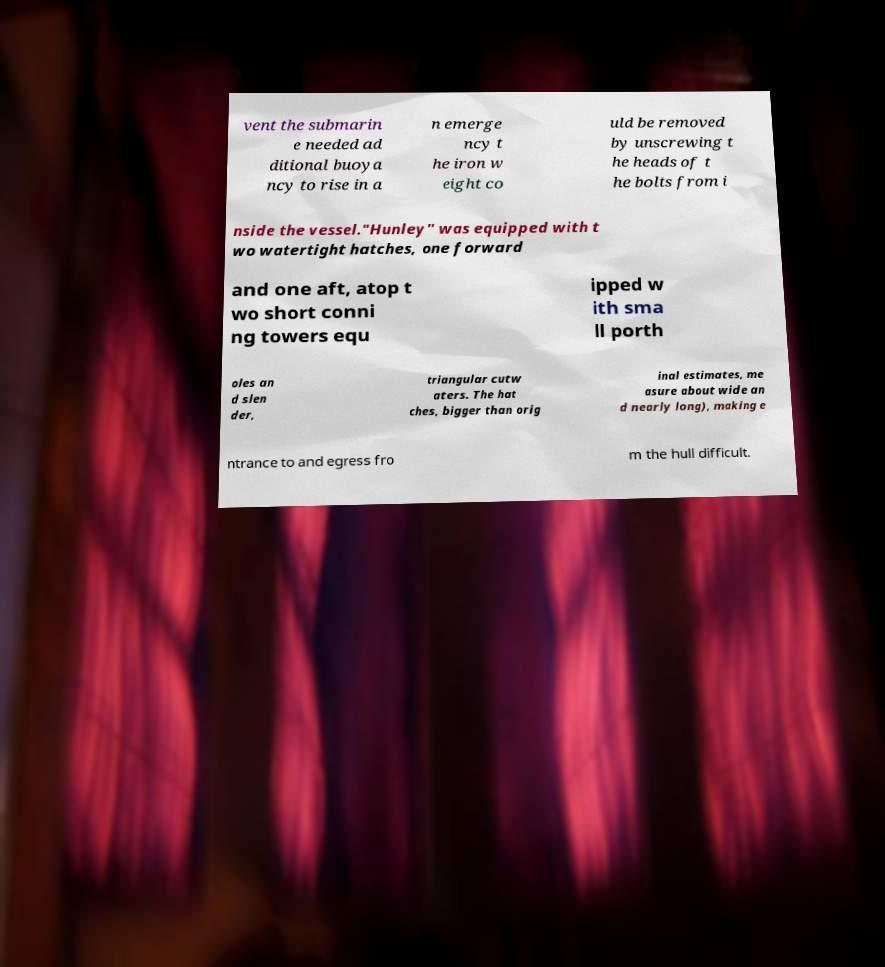Could you extract and type out the text from this image? vent the submarin e needed ad ditional buoya ncy to rise in a n emerge ncy t he iron w eight co uld be removed by unscrewing t he heads of t he bolts from i nside the vessel."Hunley" was equipped with t wo watertight hatches, one forward and one aft, atop t wo short conni ng towers equ ipped w ith sma ll porth oles an d slen der, triangular cutw aters. The hat ches, bigger than orig inal estimates, me asure about wide an d nearly long), making e ntrance to and egress fro m the hull difficult. 